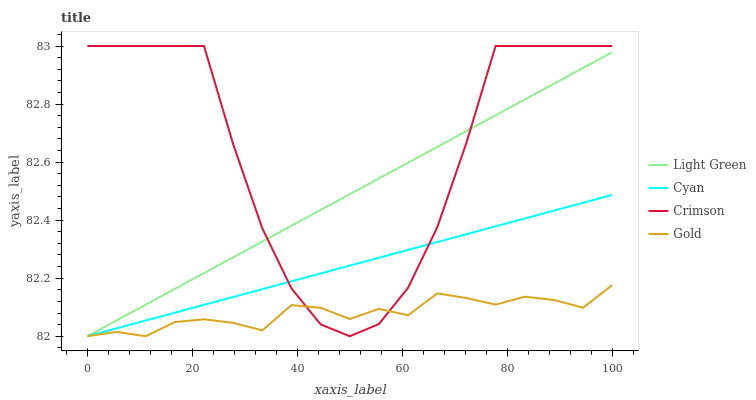Does Gold have the minimum area under the curve?
Answer yes or no. Yes. Does Crimson have the maximum area under the curve?
Answer yes or no. Yes. Does Cyan have the minimum area under the curve?
Answer yes or no. No. Does Cyan have the maximum area under the curve?
Answer yes or no. No. Is Cyan the smoothest?
Answer yes or no. Yes. Is Crimson the roughest?
Answer yes or no. Yes. Is Gold the smoothest?
Answer yes or no. No. Is Gold the roughest?
Answer yes or no. No. Does Cyan have the lowest value?
Answer yes or no. Yes. Does Crimson have the highest value?
Answer yes or no. Yes. Does Cyan have the highest value?
Answer yes or no. No. Does Gold intersect Cyan?
Answer yes or no. Yes. Is Gold less than Cyan?
Answer yes or no. No. Is Gold greater than Cyan?
Answer yes or no. No. 